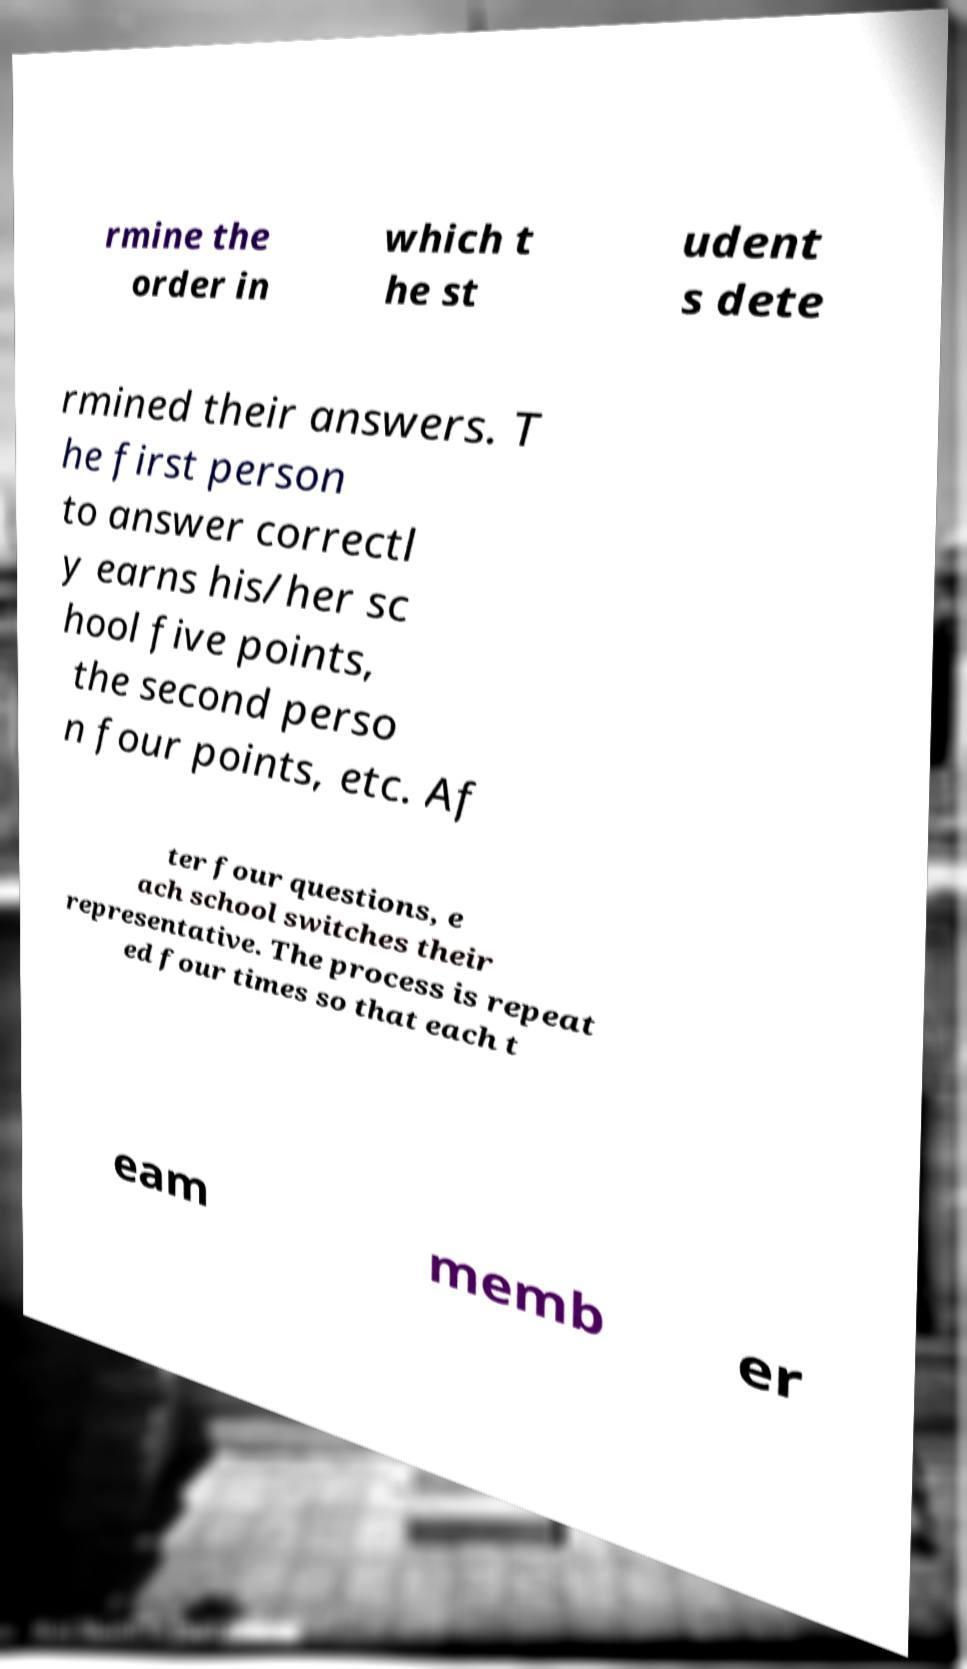Could you extract and type out the text from this image? rmine the order in which t he st udent s dete rmined their answers. T he first person to answer correctl y earns his/her sc hool five points, the second perso n four points, etc. Af ter four questions, e ach school switches their representative. The process is repeat ed four times so that each t eam memb er 